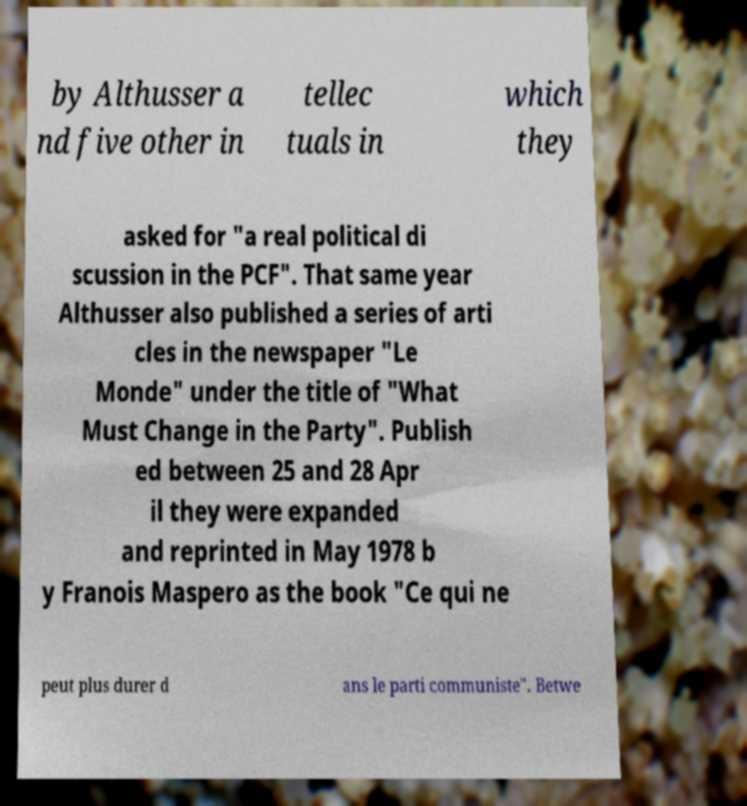What messages or text are displayed in this image? I need them in a readable, typed format. by Althusser a nd five other in tellec tuals in which they asked for "a real political di scussion in the PCF". That same year Althusser also published a series of arti cles in the newspaper "Le Monde" under the title of "What Must Change in the Party". Publish ed between 25 and 28 Apr il they were expanded and reprinted in May 1978 b y Franois Maspero as the book "Ce qui ne peut plus durer d ans le parti communiste". Betwe 